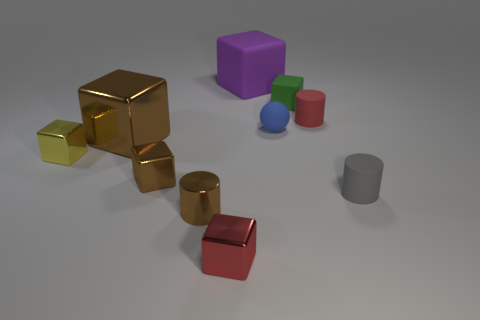What might be the purpose of these objects? Given their simplistic geometric shapes, they could be used for a variety of purposes such as educational tools for teaching shapes and colors, elements in a visual composition study, or simply as decor. Do the objects have any distinct textures? Yes, the objects exhibit a range of textures. Some blocks are shiny and reflective, like the golden ones, while others, like the gray cylinder, have a dull, matte finish. 